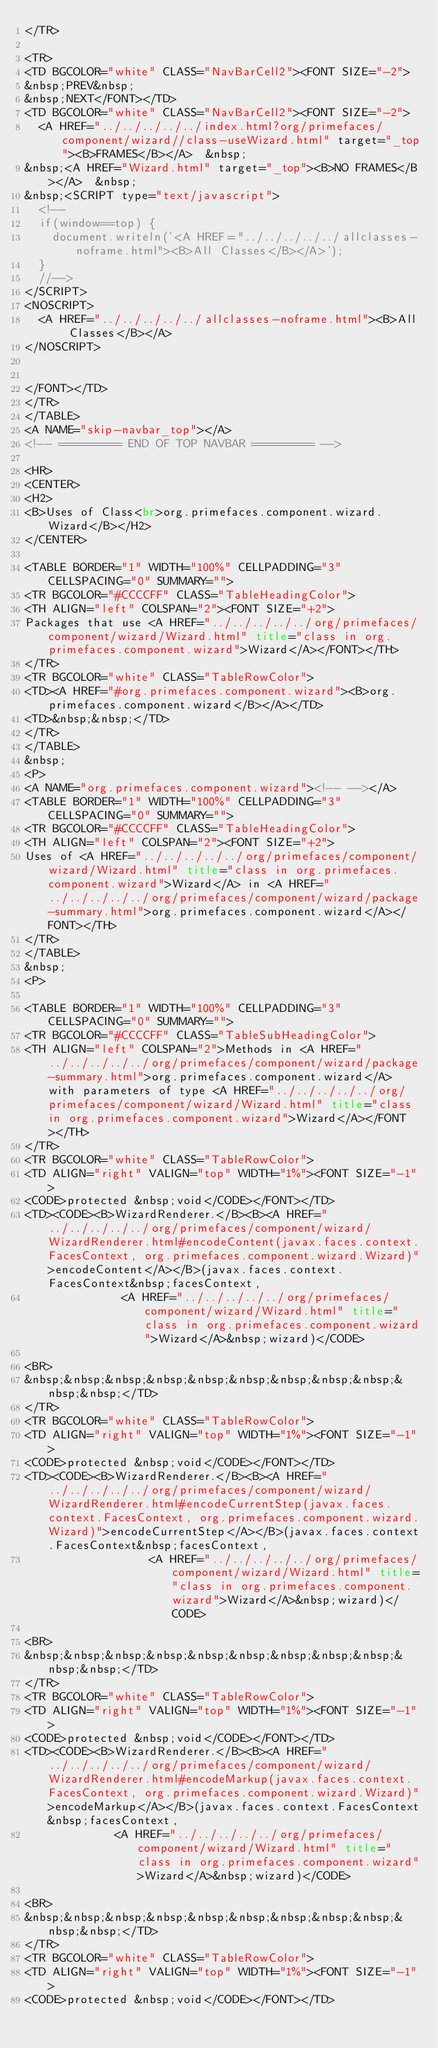<code> <loc_0><loc_0><loc_500><loc_500><_HTML_></TR>

<TR>
<TD BGCOLOR="white" CLASS="NavBarCell2"><FONT SIZE="-2">
&nbsp;PREV&nbsp;
&nbsp;NEXT</FONT></TD>
<TD BGCOLOR="white" CLASS="NavBarCell2"><FONT SIZE="-2">
  <A HREF="../../../../../index.html?org/primefaces/component/wizard//class-useWizard.html" target="_top"><B>FRAMES</B></A>  &nbsp;
&nbsp;<A HREF="Wizard.html" target="_top"><B>NO FRAMES</B></A>  &nbsp;
&nbsp;<SCRIPT type="text/javascript">
  <!--
  if(window==top) {
    document.writeln('<A HREF="../../../../../allclasses-noframe.html"><B>All Classes</B></A>');
  }
  //-->
</SCRIPT>
<NOSCRIPT>
  <A HREF="../../../../../allclasses-noframe.html"><B>All Classes</B></A>
</NOSCRIPT>


</FONT></TD>
</TR>
</TABLE>
<A NAME="skip-navbar_top"></A>
<!-- ========= END OF TOP NAVBAR ========= -->

<HR>
<CENTER>
<H2>
<B>Uses of Class<br>org.primefaces.component.wizard.Wizard</B></H2>
</CENTER>

<TABLE BORDER="1" WIDTH="100%" CELLPADDING="3" CELLSPACING="0" SUMMARY="">
<TR BGCOLOR="#CCCCFF" CLASS="TableHeadingColor">
<TH ALIGN="left" COLSPAN="2"><FONT SIZE="+2">
Packages that use <A HREF="../../../../../org/primefaces/component/wizard/Wizard.html" title="class in org.primefaces.component.wizard">Wizard</A></FONT></TH>
</TR>
<TR BGCOLOR="white" CLASS="TableRowColor">
<TD><A HREF="#org.primefaces.component.wizard"><B>org.primefaces.component.wizard</B></A></TD>
<TD>&nbsp;&nbsp;</TD>
</TR>
</TABLE>
&nbsp;
<P>
<A NAME="org.primefaces.component.wizard"><!-- --></A>
<TABLE BORDER="1" WIDTH="100%" CELLPADDING="3" CELLSPACING="0" SUMMARY="">
<TR BGCOLOR="#CCCCFF" CLASS="TableHeadingColor">
<TH ALIGN="left" COLSPAN="2"><FONT SIZE="+2">
Uses of <A HREF="../../../../../org/primefaces/component/wizard/Wizard.html" title="class in org.primefaces.component.wizard">Wizard</A> in <A HREF="../../../../../org/primefaces/component/wizard/package-summary.html">org.primefaces.component.wizard</A></FONT></TH>
</TR>
</TABLE>
&nbsp;
<P>

<TABLE BORDER="1" WIDTH="100%" CELLPADDING="3" CELLSPACING="0" SUMMARY="">
<TR BGCOLOR="#CCCCFF" CLASS="TableSubHeadingColor">
<TH ALIGN="left" COLSPAN="2">Methods in <A HREF="../../../../../org/primefaces/component/wizard/package-summary.html">org.primefaces.component.wizard</A> with parameters of type <A HREF="../../../../../org/primefaces/component/wizard/Wizard.html" title="class in org.primefaces.component.wizard">Wizard</A></FONT></TH>
</TR>
<TR BGCOLOR="white" CLASS="TableRowColor">
<TD ALIGN="right" VALIGN="top" WIDTH="1%"><FONT SIZE="-1">
<CODE>protected &nbsp;void</CODE></FONT></TD>
<TD><CODE><B>WizardRenderer.</B><B><A HREF="../../../../../org/primefaces/component/wizard/WizardRenderer.html#encodeContent(javax.faces.context.FacesContext, org.primefaces.component.wizard.Wizard)">encodeContent</A></B>(javax.faces.context.FacesContext&nbsp;facesContext,
              <A HREF="../../../../../org/primefaces/component/wizard/Wizard.html" title="class in org.primefaces.component.wizard">Wizard</A>&nbsp;wizard)</CODE>

<BR>
&nbsp;&nbsp;&nbsp;&nbsp;&nbsp;&nbsp;&nbsp;&nbsp;&nbsp;&nbsp;&nbsp;</TD>
</TR>
<TR BGCOLOR="white" CLASS="TableRowColor">
<TD ALIGN="right" VALIGN="top" WIDTH="1%"><FONT SIZE="-1">
<CODE>protected &nbsp;void</CODE></FONT></TD>
<TD><CODE><B>WizardRenderer.</B><B><A HREF="../../../../../org/primefaces/component/wizard/WizardRenderer.html#encodeCurrentStep(javax.faces.context.FacesContext, org.primefaces.component.wizard.Wizard)">encodeCurrentStep</A></B>(javax.faces.context.FacesContext&nbsp;facesContext,
                  <A HREF="../../../../../org/primefaces/component/wizard/Wizard.html" title="class in org.primefaces.component.wizard">Wizard</A>&nbsp;wizard)</CODE>

<BR>
&nbsp;&nbsp;&nbsp;&nbsp;&nbsp;&nbsp;&nbsp;&nbsp;&nbsp;&nbsp;&nbsp;</TD>
</TR>
<TR BGCOLOR="white" CLASS="TableRowColor">
<TD ALIGN="right" VALIGN="top" WIDTH="1%"><FONT SIZE="-1">
<CODE>protected &nbsp;void</CODE></FONT></TD>
<TD><CODE><B>WizardRenderer.</B><B><A HREF="../../../../../org/primefaces/component/wizard/WizardRenderer.html#encodeMarkup(javax.faces.context.FacesContext, org.primefaces.component.wizard.Wizard)">encodeMarkup</A></B>(javax.faces.context.FacesContext&nbsp;facesContext,
             <A HREF="../../../../../org/primefaces/component/wizard/Wizard.html" title="class in org.primefaces.component.wizard">Wizard</A>&nbsp;wizard)</CODE>

<BR>
&nbsp;&nbsp;&nbsp;&nbsp;&nbsp;&nbsp;&nbsp;&nbsp;&nbsp;&nbsp;&nbsp;</TD>
</TR>
<TR BGCOLOR="white" CLASS="TableRowColor">
<TD ALIGN="right" VALIGN="top" WIDTH="1%"><FONT SIZE="-1">
<CODE>protected &nbsp;void</CODE></FONT></TD></code> 